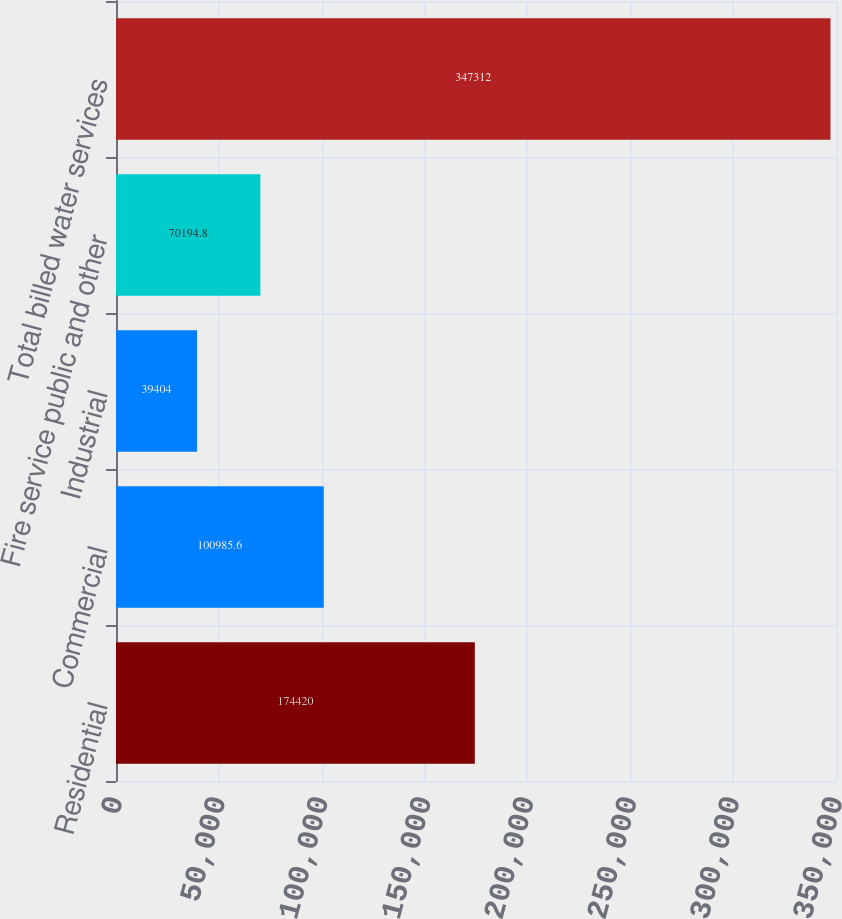<chart> <loc_0><loc_0><loc_500><loc_500><bar_chart><fcel>Residential<fcel>Commercial<fcel>Industrial<fcel>Fire service public and other<fcel>Total billed water services<nl><fcel>174420<fcel>100986<fcel>39404<fcel>70194.8<fcel>347312<nl></chart> 